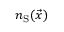Convert formula to latex. <formula><loc_0><loc_0><loc_500><loc_500>n _ { S } ( \vec { x } )</formula> 